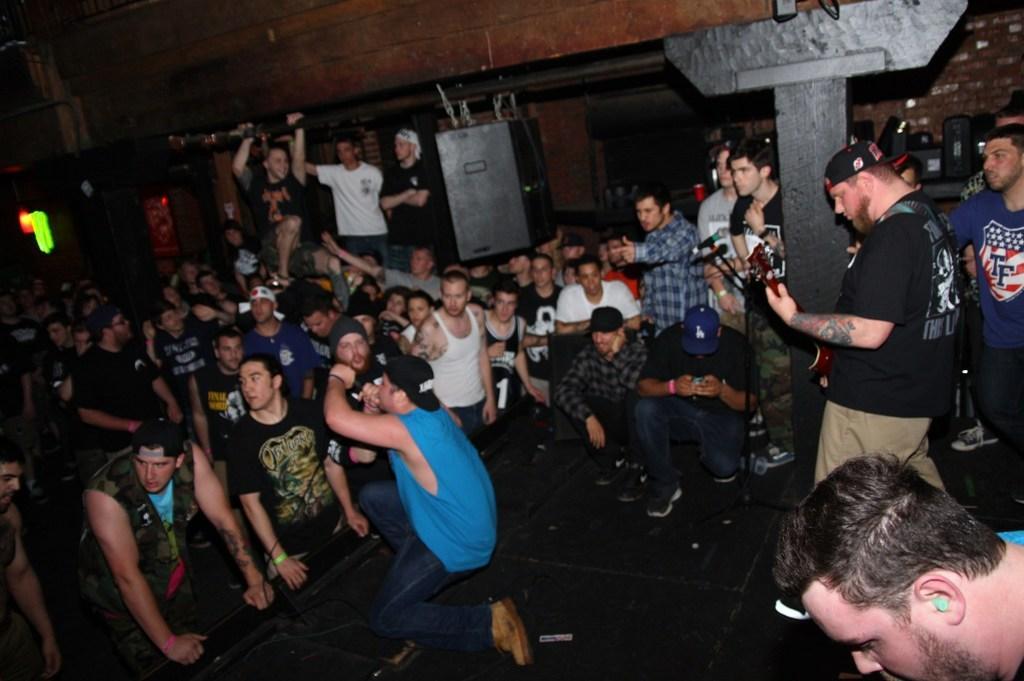Describe this image in one or two sentences. In this image we can see a few people, among them some people are holding the objects, also we can see a pole, pillar, wall and some other objects, there is an object hanged to the pole. 